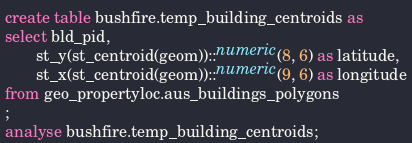Convert code to text. <code><loc_0><loc_0><loc_500><loc_500><_SQL_>create table bushfire.temp_building_centroids as
select bld_pid,
       st_y(st_centroid(geom))::numeric(8, 6) as latitude,
       st_x(st_centroid(geom))::numeric(9, 6) as longitude
from geo_propertyloc.aus_buildings_polygons
;
analyse bushfire.temp_building_centroids;
</code> 